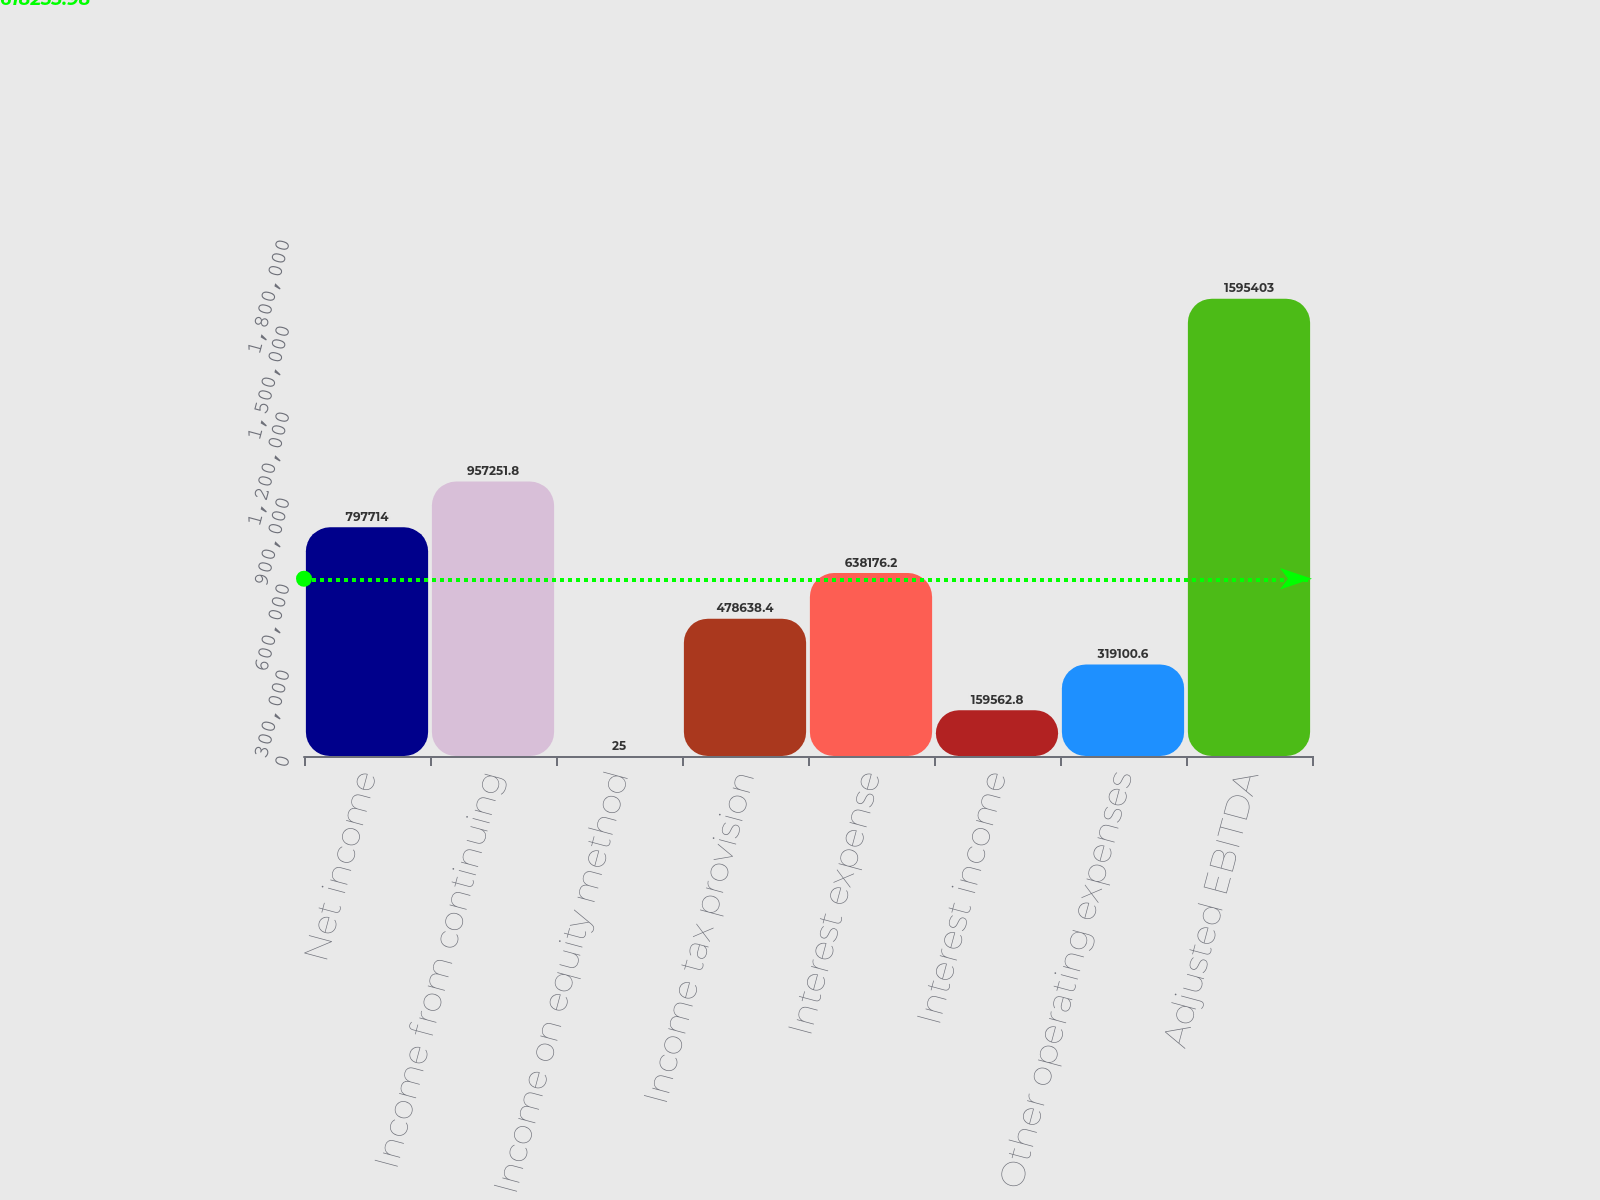Convert chart to OTSL. <chart><loc_0><loc_0><loc_500><loc_500><bar_chart><fcel>Net income<fcel>Income from continuing<fcel>Income on equity method<fcel>Income tax provision<fcel>Interest expense<fcel>Interest income<fcel>Other operating expenses<fcel>Adjusted EBITDA<nl><fcel>797714<fcel>957252<fcel>25<fcel>478638<fcel>638176<fcel>159563<fcel>319101<fcel>1.5954e+06<nl></chart> 